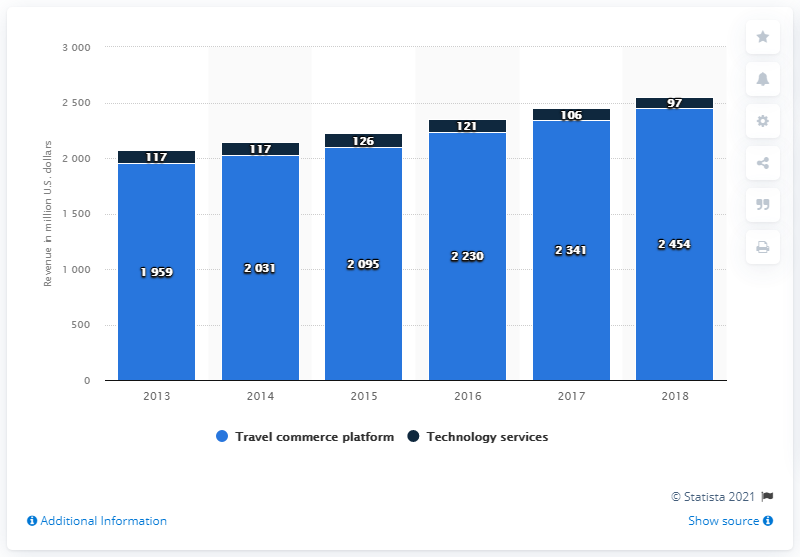List a handful of essential elements in this visual. In 2018, Travelport generated a total revenue of approximately 2454. 